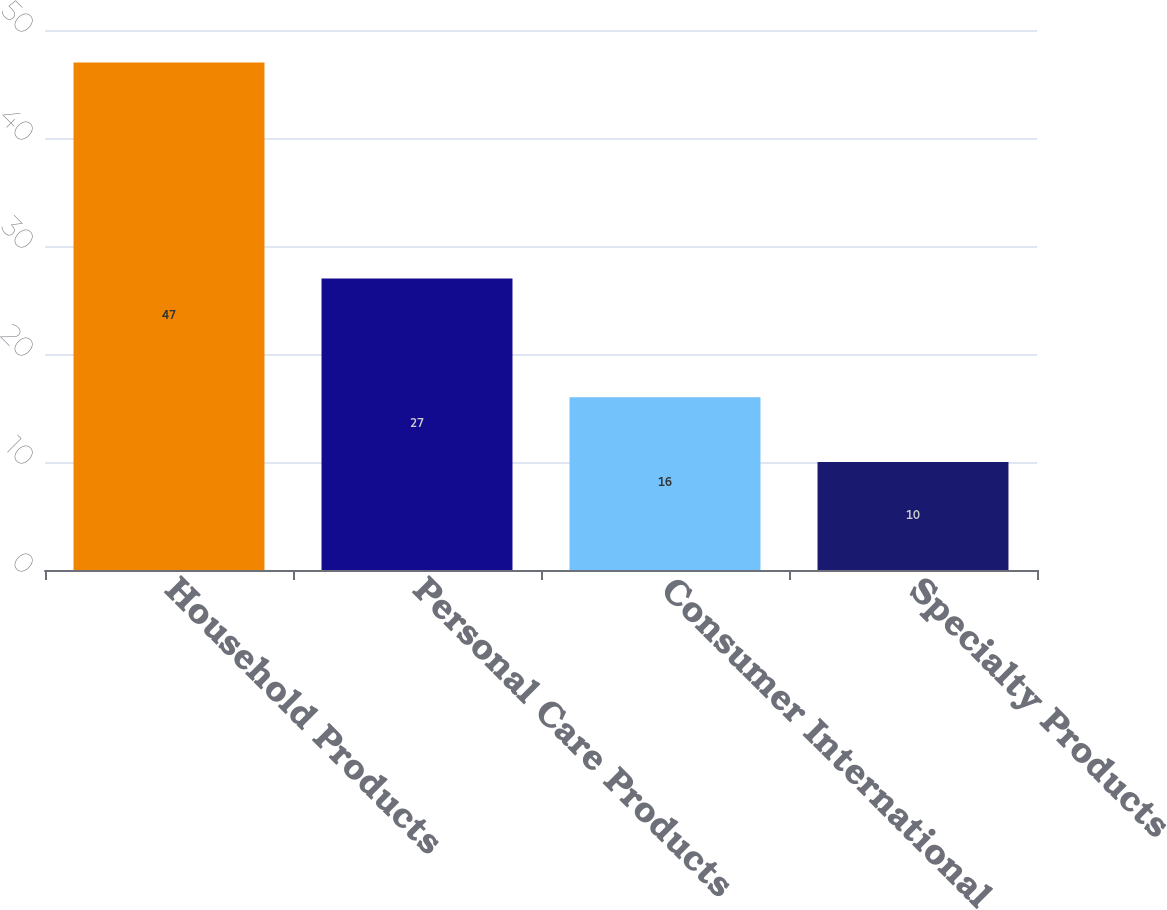Convert chart to OTSL. <chart><loc_0><loc_0><loc_500><loc_500><bar_chart><fcel>Household Products<fcel>Personal Care Products<fcel>Consumer International<fcel>Specialty Products<nl><fcel>47<fcel>27<fcel>16<fcel>10<nl></chart> 